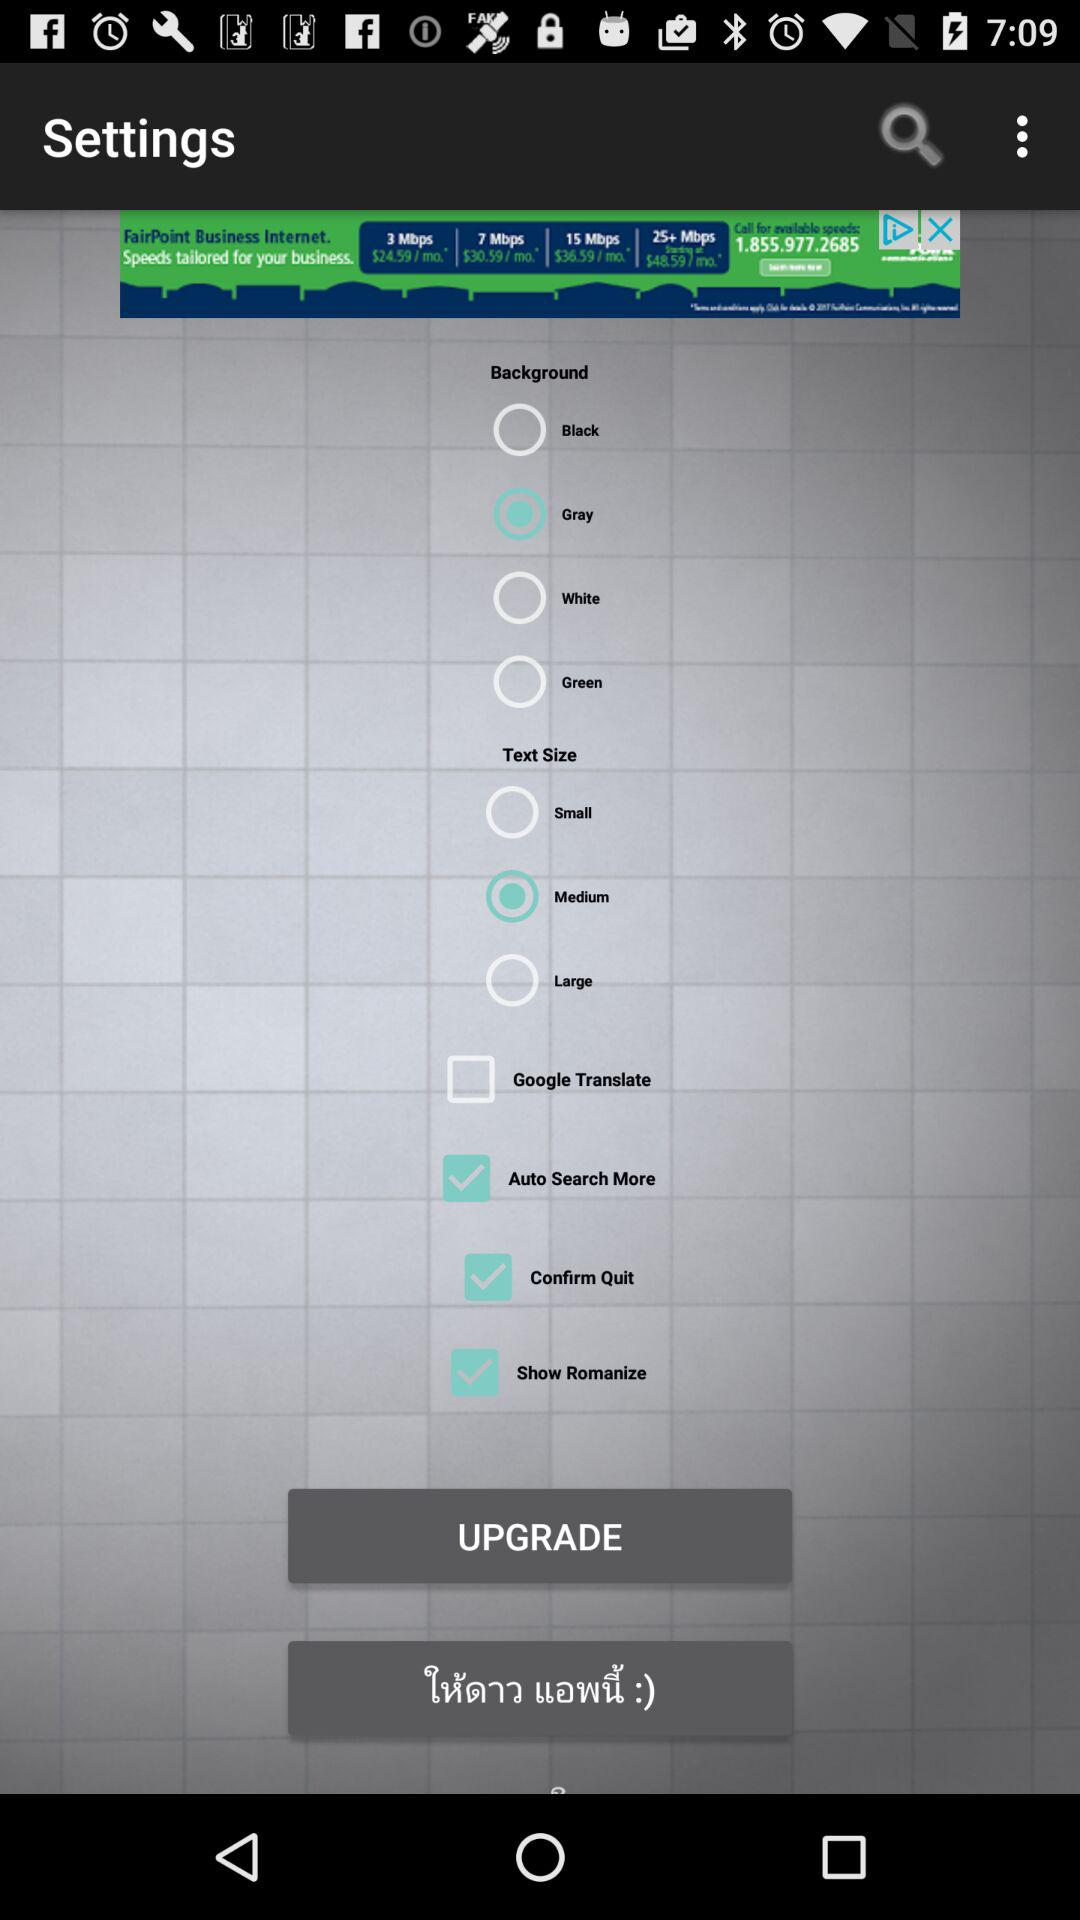What option has been selected in the "Background"? The selected option is "Gray". 